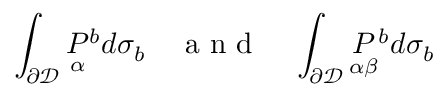Convert formula to latex. <formula><loc_0><loc_0><loc_500><loc_500>\int _ { \partial \mathcal { D } } \underset { \alpha } { P ^ { b } d \sigma _ { b } \quad a n d \quad \int _ { \partial \mathcal { D } } \underset { \alpha \beta } { P ^ { b } d \sigma _ { b }</formula> 